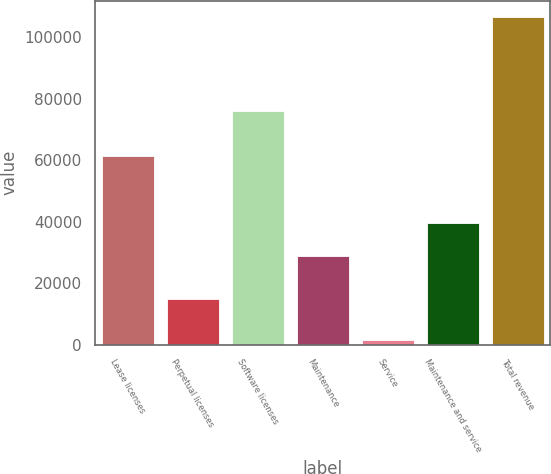Convert chart. <chart><loc_0><loc_0><loc_500><loc_500><bar_chart><fcel>Lease licenses<fcel>Perpetual licenses<fcel>Software licenses<fcel>Maintenance<fcel>Service<fcel>Maintenance and service<fcel>Total revenue<nl><fcel>61278<fcel>14711<fcel>75989<fcel>28952<fcel>1628<fcel>39446.1<fcel>106569<nl></chart> 